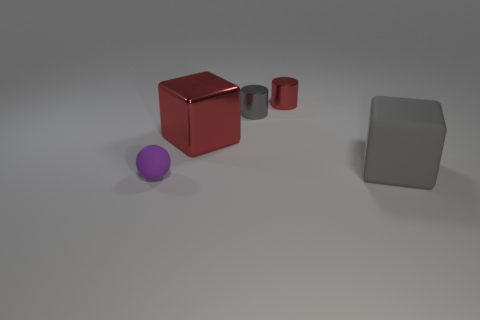Add 2 tiny metal cylinders. How many objects exist? 7 Subtract all cylinders. How many objects are left? 3 Subtract 0 purple cylinders. How many objects are left? 5 Subtract all cyan cubes. Subtract all blue spheres. How many cubes are left? 2 Subtract all blocks. Subtract all matte spheres. How many objects are left? 2 Add 5 small red metallic cylinders. How many small red metallic cylinders are left? 6 Add 4 tiny metallic things. How many tiny metallic things exist? 6 